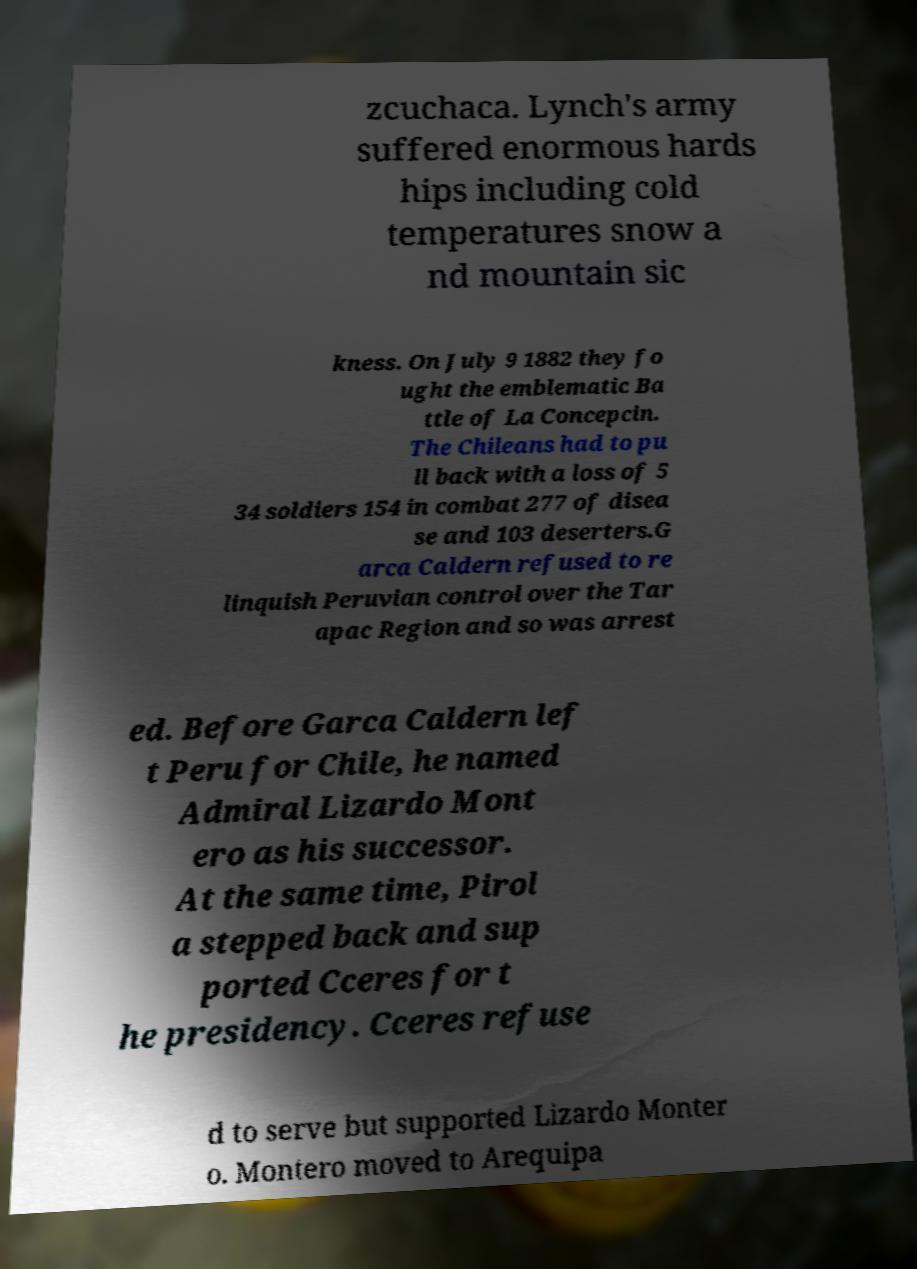Please identify and transcribe the text found in this image. zcuchaca. Lynch's army suffered enormous hards hips including cold temperatures snow a nd mountain sic kness. On July 9 1882 they fo ught the emblematic Ba ttle of La Concepcin. The Chileans had to pu ll back with a loss of 5 34 soldiers 154 in combat 277 of disea se and 103 deserters.G arca Caldern refused to re linquish Peruvian control over the Tar apac Region and so was arrest ed. Before Garca Caldern lef t Peru for Chile, he named Admiral Lizardo Mont ero as his successor. At the same time, Pirol a stepped back and sup ported Cceres for t he presidency. Cceres refuse d to serve but supported Lizardo Monter o. Montero moved to Arequipa 